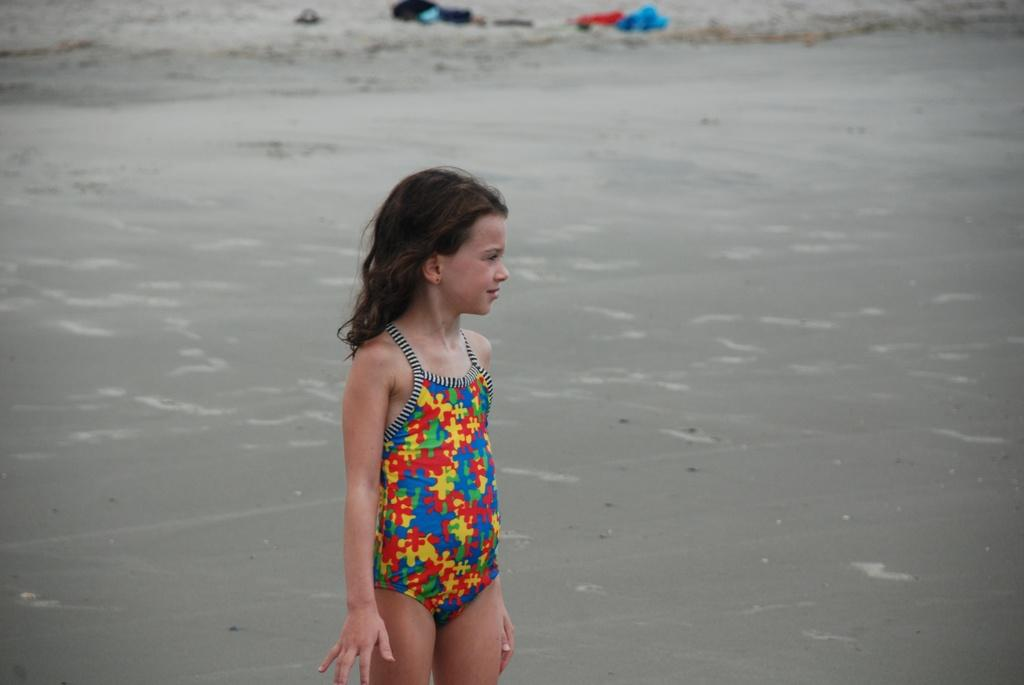What is the girl in the image wearing? The girl is wearing a bikini in the image. What is the girl's posture in the image? The girl is standing in the image. What can be seen in the background of the image? There is water and clothes on dry land in the background of the image. What type of blade is being used by the minister in the image? There is no minister or blade present in the image. 